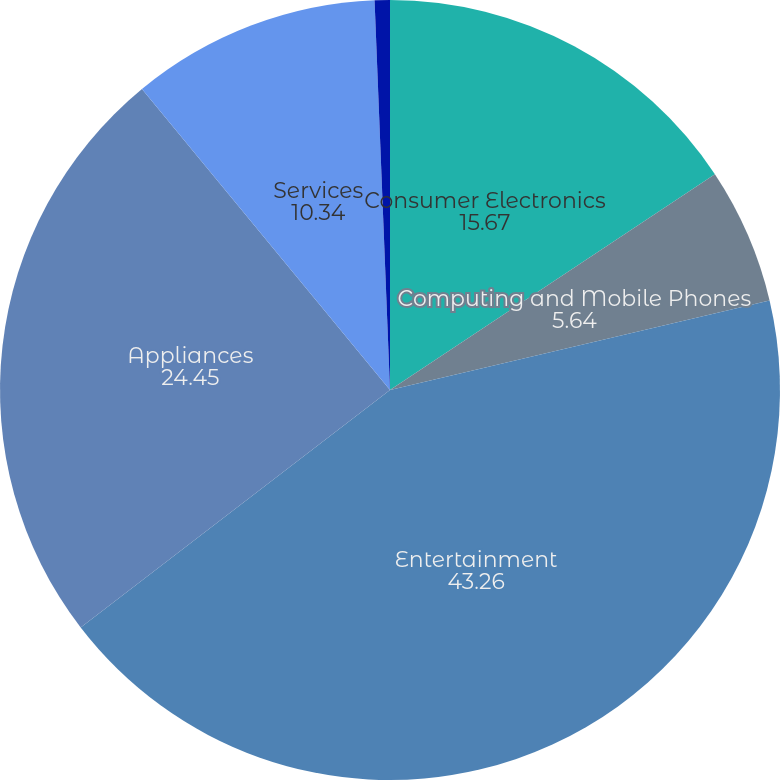Convert chart to OTSL. <chart><loc_0><loc_0><loc_500><loc_500><pie_chart><fcel>Consumer Electronics<fcel>Computing and Mobile Phones<fcel>Entertainment<fcel>Appliances<fcel>Services<fcel>Total<nl><fcel>15.67%<fcel>5.64%<fcel>43.26%<fcel>24.45%<fcel>10.34%<fcel>0.63%<nl></chart> 